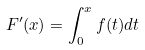Convert formula to latex. <formula><loc_0><loc_0><loc_500><loc_500>F ^ { \prime } ( x ) = \int _ { 0 } ^ { x } f ( t ) d t</formula> 